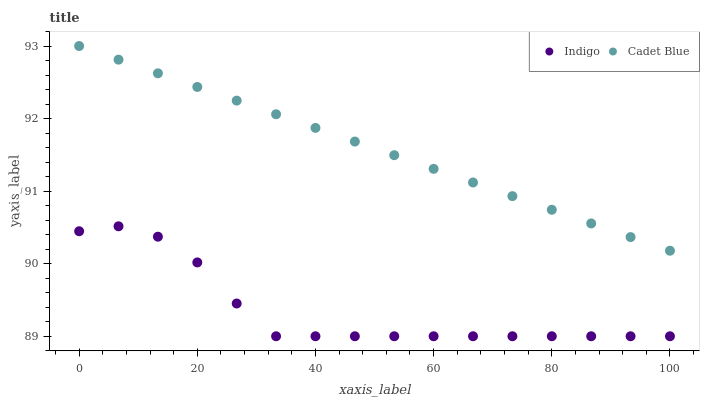Does Indigo have the minimum area under the curve?
Answer yes or no. Yes. Does Cadet Blue have the maximum area under the curve?
Answer yes or no. Yes. Does Indigo have the maximum area under the curve?
Answer yes or no. No. Is Cadet Blue the smoothest?
Answer yes or no. Yes. Is Indigo the roughest?
Answer yes or no. Yes. Is Indigo the smoothest?
Answer yes or no. No. Does Indigo have the lowest value?
Answer yes or no. Yes. Does Cadet Blue have the highest value?
Answer yes or no. Yes. Does Indigo have the highest value?
Answer yes or no. No. Is Indigo less than Cadet Blue?
Answer yes or no. Yes. Is Cadet Blue greater than Indigo?
Answer yes or no. Yes. Does Indigo intersect Cadet Blue?
Answer yes or no. No. 